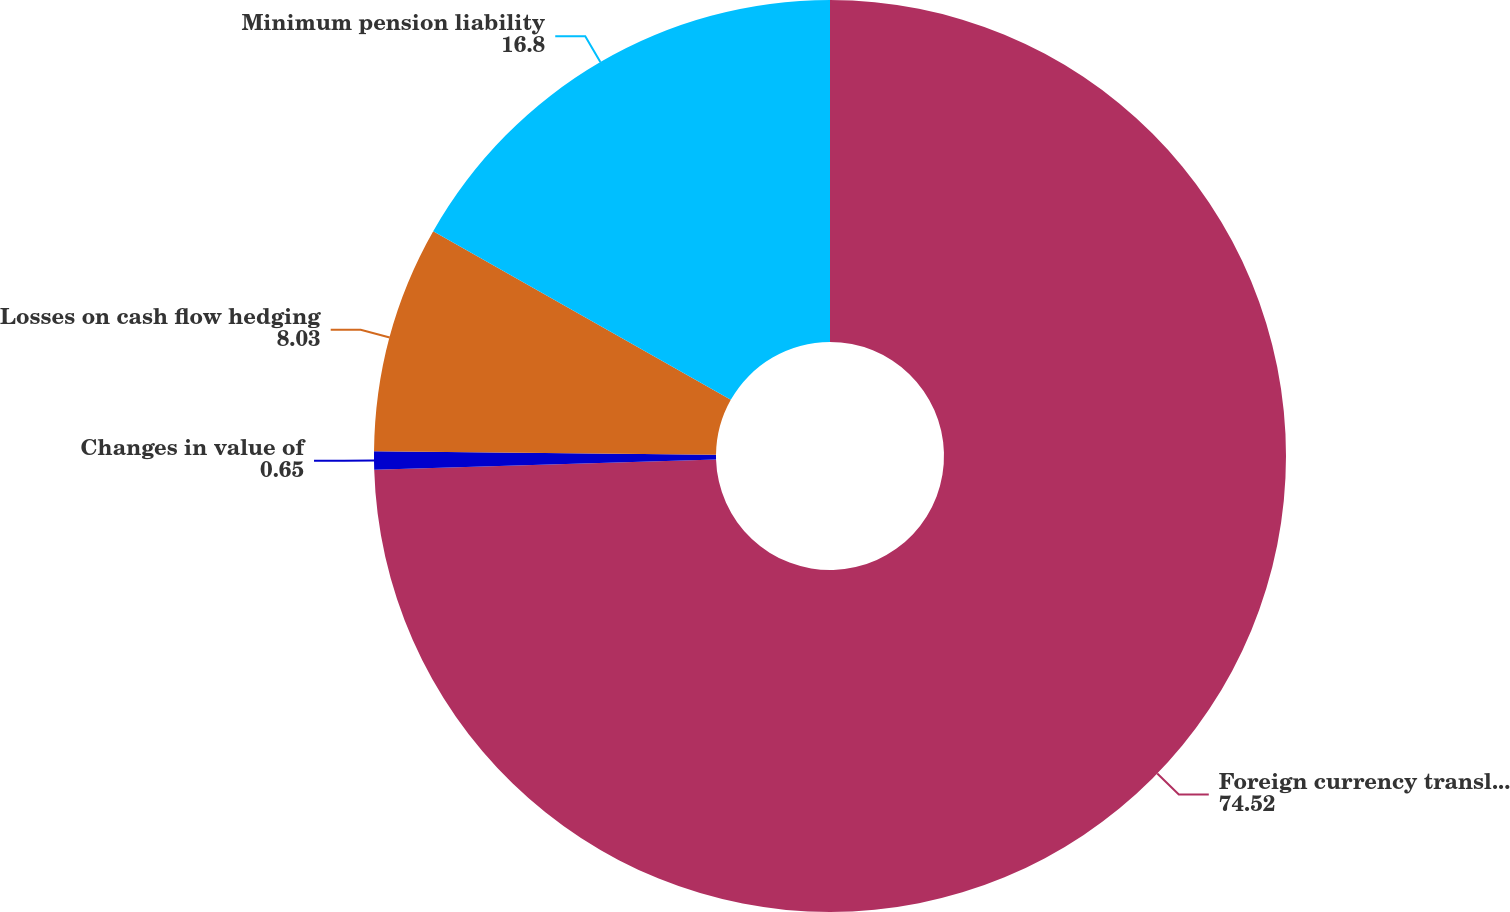Convert chart to OTSL. <chart><loc_0><loc_0><loc_500><loc_500><pie_chart><fcel>Foreign currency translation<fcel>Changes in value of<fcel>Losses on cash flow hedging<fcel>Minimum pension liability<nl><fcel>74.52%<fcel>0.65%<fcel>8.03%<fcel>16.8%<nl></chart> 